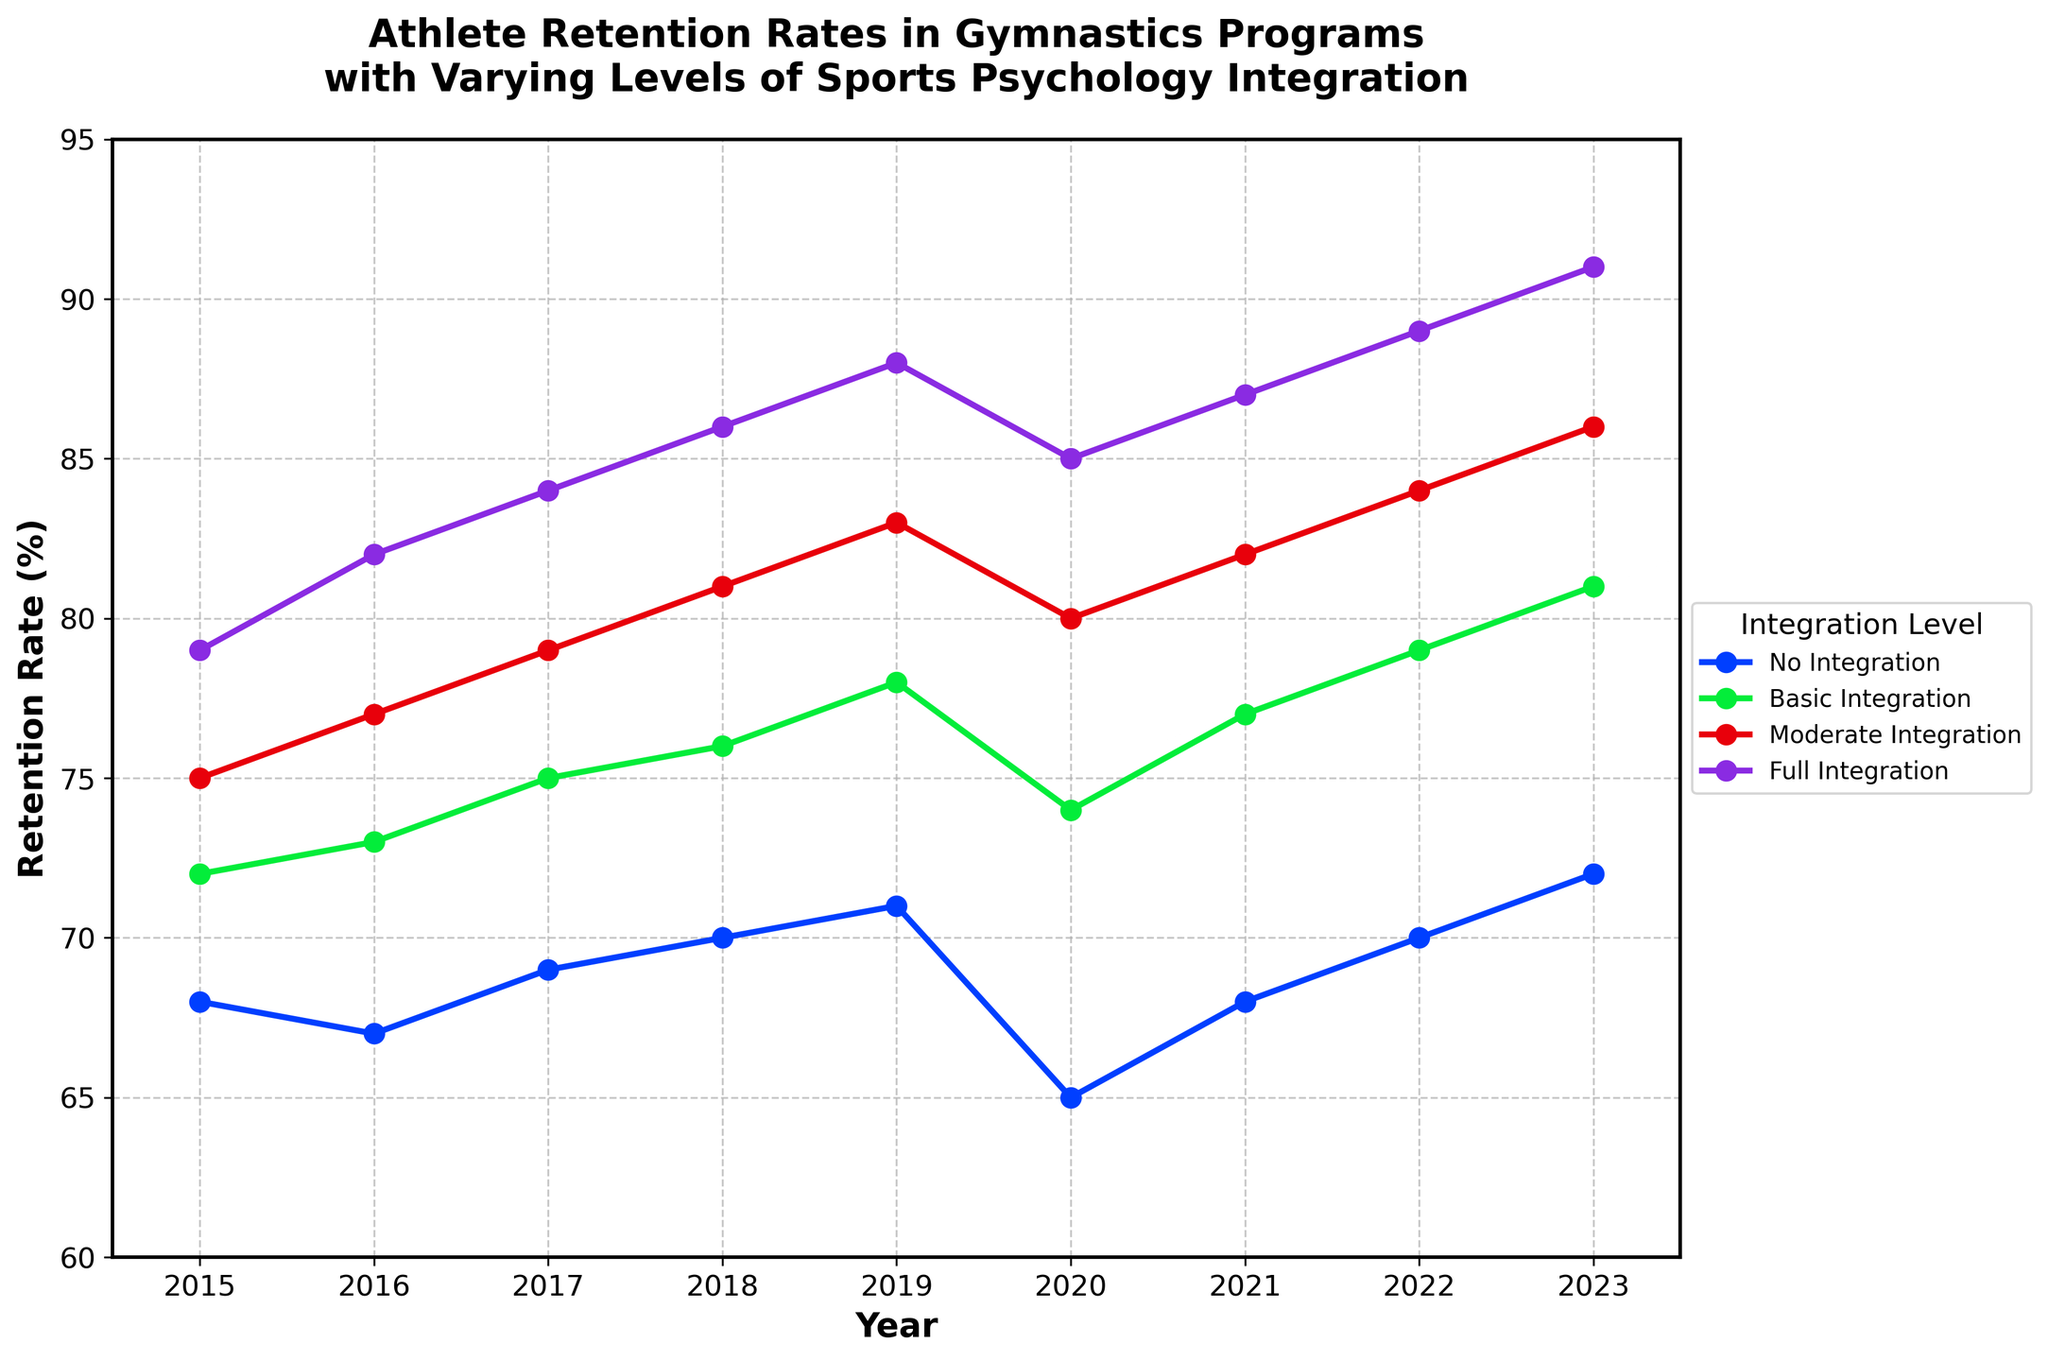What was the retention rate in 2018 for programs with Full Integration of sports psychology? The figure shows the retention rates for each year and level of integration. For Full Integration, locate the value corresponding to the year 2018.
Answer: 86% Which integration level had the lowest retention rate in 2020? Examine the retention rates for 2020 across all integration levels. The lowest value is for No Integration.
Answer: No Integration By how much did the retention rate of Basic Integration programs change from 2015 to 2023? In 2015, retention was 72%, and in 2023, it was 81%. The difference is 81% - 72%.
Answer: 9% Compare the retention rate trend between Moderate Integration and Full Integration from 2015 to 2023. Which one had a steeper increase? To compare trends, look at the initial and final values for both categories. Moderate Integration goes from 75% to 86%, and Full Integration goes from 79% to 91%. Calculate the increases (11% for Moderate, 12% for Full) to determine which is steeper.
Answer: Full Integration What is the average retention rate for Basic Integration from 2015 to 2023? Sum up the retention rates of Basic Integration for each year (72 + 73 + 75 + 76 + 78 + 74 + 77 + 79 + 81 = 685) and divide by the number of years (9).
Answer: 76.1% Which year experienced the highest overall retention across all integration levels? Compare the values for each year across all integration levels to find the highest value. 2023 has the highest value of 91% in Full Integration.
Answer: 2023 What is the visual distinction among the lines representing different levels of sports psychology integration? The lines vary in color and style, with markers at data points, labeled in the legend for easy identification.
Answer: Colors and markers How did retention rates for No Integration programs change from 2019 to 2020? The retention rate dropped from 71% in 2019 to 65% in 2020. Calculate the decrease (71% - 65%).
Answer: 6% decrease Which integration level consistently had higher retention rates over the years 2015-2023? Examine each line's position across the years to find the highest overall line, which is Full Integration.
Answer: Full Integration How did the average retention rate change across all levels of integration from 2015 to 2023? Calculate the average retention for each year across all levels and compare 2015 to 2023. For 2015, average = (68+72+75+79)/4 = 73.5. For 2023, average = (72+81+86+91)/4 = 82.5. The change is 82.5 - 73.5.
Answer: 9% increase 